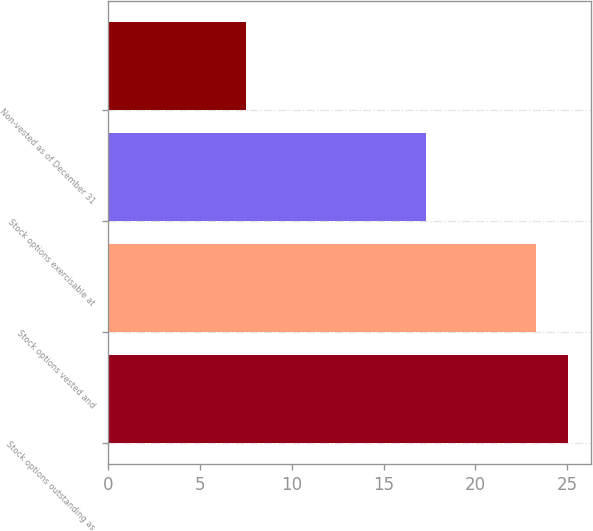Convert chart to OTSL. <chart><loc_0><loc_0><loc_500><loc_500><bar_chart><fcel>Stock options outstanding as<fcel>Stock options vested and<fcel>Stock options exercisable at<fcel>Non-vested as of December 31<nl><fcel>25.03<fcel>23.3<fcel>17.3<fcel>7.5<nl></chart> 